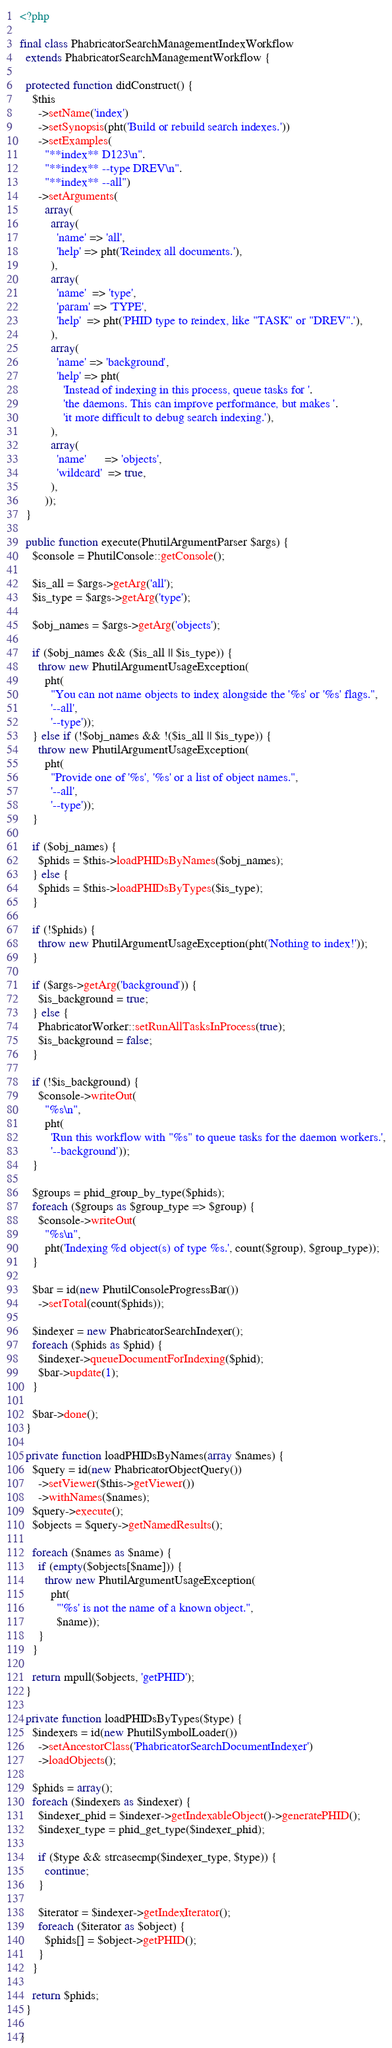<code> <loc_0><loc_0><loc_500><loc_500><_PHP_><?php

final class PhabricatorSearchManagementIndexWorkflow
  extends PhabricatorSearchManagementWorkflow {

  protected function didConstruct() {
    $this
      ->setName('index')
      ->setSynopsis(pht('Build or rebuild search indexes.'))
      ->setExamples(
        "**index** D123\n".
        "**index** --type DREV\n".
        "**index** --all")
      ->setArguments(
        array(
          array(
            'name' => 'all',
            'help' => pht('Reindex all documents.'),
          ),
          array(
            'name'  => 'type',
            'param' => 'TYPE',
            'help'  => pht('PHID type to reindex, like "TASK" or "DREV".'),
          ),
          array(
            'name' => 'background',
            'help' => pht(
              'Instead of indexing in this process, queue tasks for '.
              'the daemons. This can improve performance, but makes '.
              'it more difficult to debug search indexing.'),
          ),
          array(
            'name'      => 'objects',
            'wildcard'  => true,
          ),
        ));
  }

  public function execute(PhutilArgumentParser $args) {
    $console = PhutilConsole::getConsole();

    $is_all = $args->getArg('all');
    $is_type = $args->getArg('type');

    $obj_names = $args->getArg('objects');

    if ($obj_names && ($is_all || $is_type)) {
      throw new PhutilArgumentUsageException(
        pht(
          "You can not name objects to index alongside the '%s' or '%s' flags.",
          '--all',
          '--type'));
    } else if (!$obj_names && !($is_all || $is_type)) {
      throw new PhutilArgumentUsageException(
        pht(
          "Provide one of '%s', '%s' or a list of object names.",
          '--all',
          '--type'));
    }

    if ($obj_names) {
      $phids = $this->loadPHIDsByNames($obj_names);
    } else {
      $phids = $this->loadPHIDsByTypes($is_type);
    }

    if (!$phids) {
      throw new PhutilArgumentUsageException(pht('Nothing to index!'));
    }

    if ($args->getArg('background')) {
      $is_background = true;
    } else {
      PhabricatorWorker::setRunAllTasksInProcess(true);
      $is_background = false;
    }

    if (!$is_background) {
      $console->writeOut(
        "%s\n",
        pht(
          'Run this workflow with "%s" to queue tasks for the daemon workers.',
          '--background'));
    }

    $groups = phid_group_by_type($phids);
    foreach ($groups as $group_type => $group) {
      $console->writeOut(
        "%s\n",
        pht('Indexing %d object(s) of type %s.', count($group), $group_type));
    }

    $bar = id(new PhutilConsoleProgressBar())
      ->setTotal(count($phids));

    $indexer = new PhabricatorSearchIndexer();
    foreach ($phids as $phid) {
      $indexer->queueDocumentForIndexing($phid);
      $bar->update(1);
    }

    $bar->done();
  }

  private function loadPHIDsByNames(array $names) {
    $query = id(new PhabricatorObjectQuery())
      ->setViewer($this->getViewer())
      ->withNames($names);
    $query->execute();
    $objects = $query->getNamedResults();

    foreach ($names as $name) {
      if (empty($objects[$name])) {
        throw new PhutilArgumentUsageException(
          pht(
            "'%s' is not the name of a known object.",
            $name));
      }
    }

    return mpull($objects, 'getPHID');
  }

  private function loadPHIDsByTypes($type) {
    $indexers = id(new PhutilSymbolLoader())
      ->setAncestorClass('PhabricatorSearchDocumentIndexer')
      ->loadObjects();

    $phids = array();
    foreach ($indexers as $indexer) {
      $indexer_phid = $indexer->getIndexableObject()->generatePHID();
      $indexer_type = phid_get_type($indexer_phid);

      if ($type && strcasecmp($indexer_type, $type)) {
        continue;
      }

      $iterator = $indexer->getIndexIterator();
      foreach ($iterator as $object) {
        $phids[] = $object->getPHID();
      }
    }

    return $phids;
  }

}
</code> 